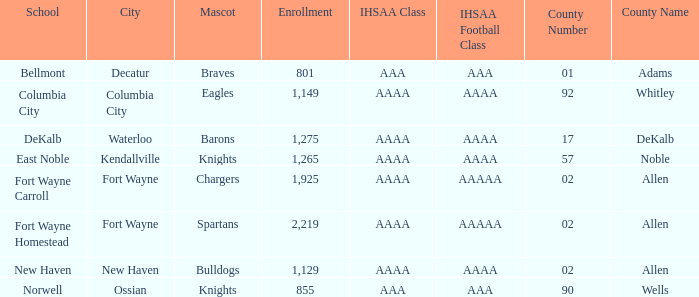What's the ihsaa football division in decatur with an aaa ihsaa group? AAA. 